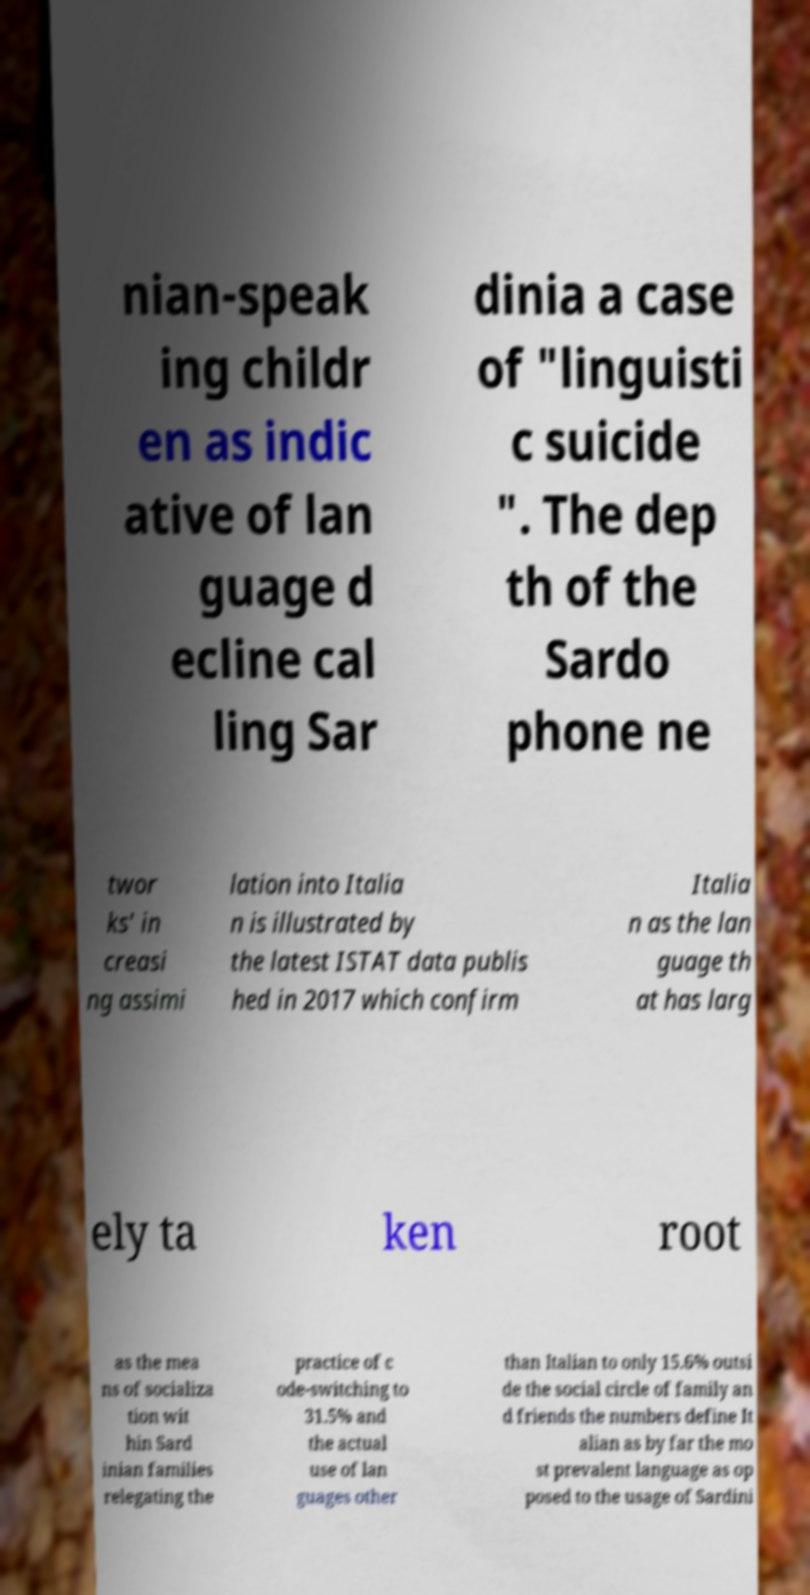Please read and relay the text visible in this image. What does it say? nian-speak ing childr en as indic ative of lan guage d ecline cal ling Sar dinia a case of "linguisti c suicide ". The dep th of the Sardo phone ne twor ks' in creasi ng assimi lation into Italia n is illustrated by the latest ISTAT data publis hed in 2017 which confirm Italia n as the lan guage th at has larg ely ta ken root as the mea ns of socializa tion wit hin Sard inian families relegating the practice of c ode-switching to 31.5% and the actual use of lan guages other than Italian to only 15.6% outsi de the social circle of family an d friends the numbers define It alian as by far the mo st prevalent language as op posed to the usage of Sardini 